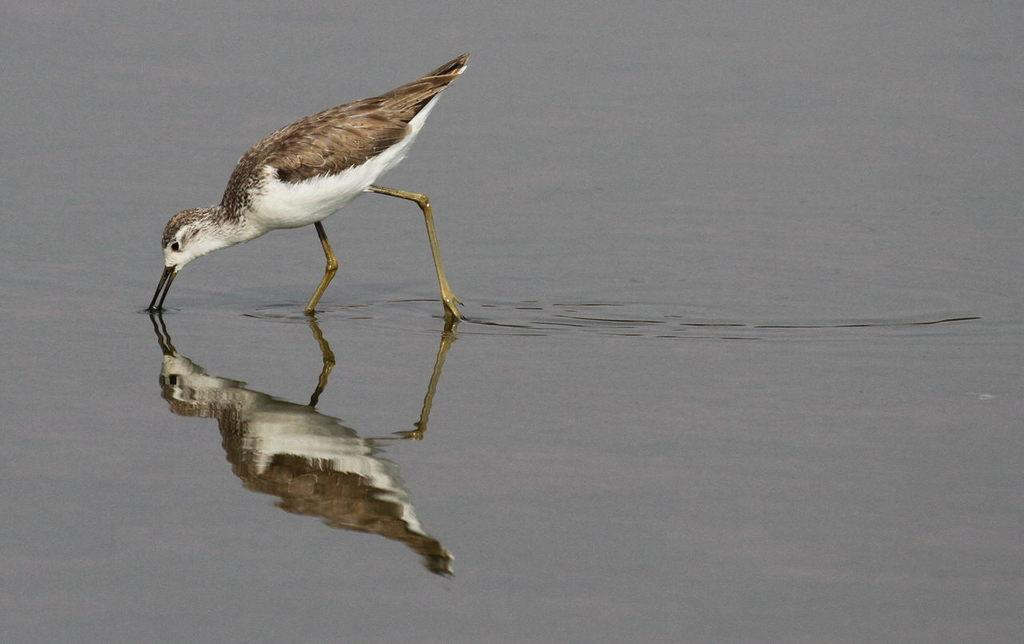What is present at the bottom of the image? There is water at the bottom of the image. Where else can water be seen in the image? Water can also be seen on the left side of the image. What is reflected in the water in the image? There is a reflection of a bird on the water in the image. Where is the girl sitting on her throne in the image? There is no girl or throne present in the image; it features water and a bird's reflection. Can you hear the bird cry in the image? There is no sound in the image, so it is not possible to hear the bird cry. 